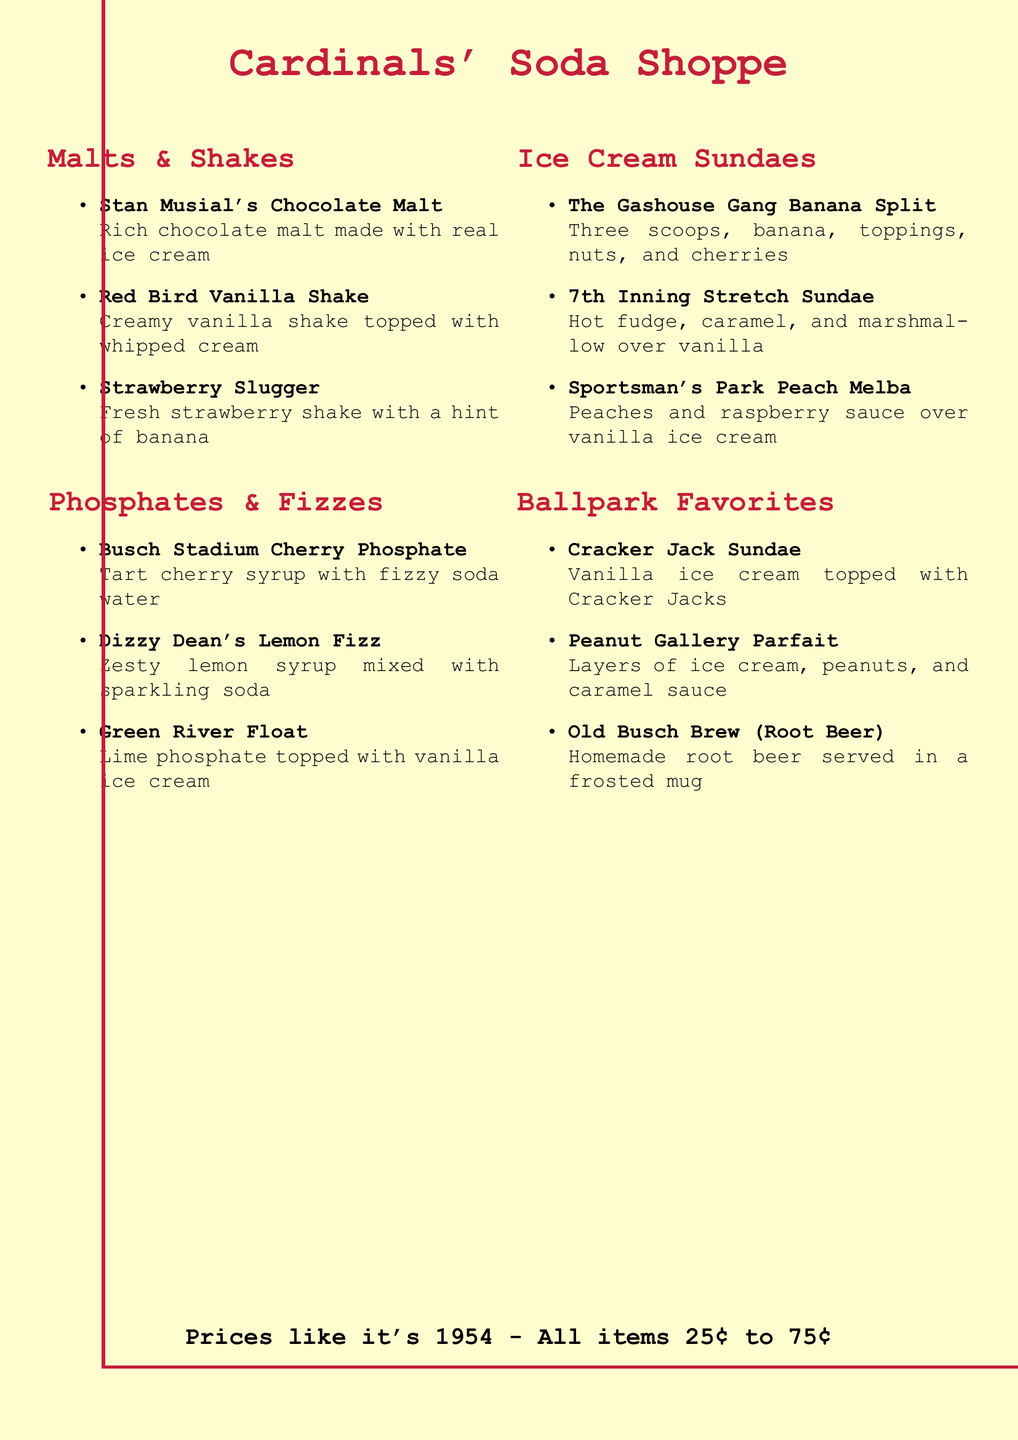What are Stan Musial's favorite flavors? The item listed under Stan Musial's name is the chocolate malt.
Answer: Chocolate Malt What is the price range for items? The document specifies that all items are priced...
Answer: 25¢ to 75¢ Which sundae includes nuts? The sundae that contains nuts is the one mentioned as...
Answer: The Gashouse Gang Banana Split How many scoops are in the banana split? The menu states that the banana split has three scoops.
Answer: Three What syrup is used in the Busch Stadium Cherry Phosphate? The specific syrup mentioned for that phosphate is tart cherry syrup.
Answer: Tart cherry syrup What item features lime phosphate? The item with lime phosphate is called the...
Answer: Green River Float What beverage is served in a frosted mug? The menu mentions a beverage served in a frosted mug, which is root beer.
Answer: Old Busch Brew (Root Beer) How is the 7th Inning Stretch Sundae topped? The toppings for the 7th Inning Stretch Sundae include hot fudge...
Answer: Hot fudge, caramel, and marshmallow 